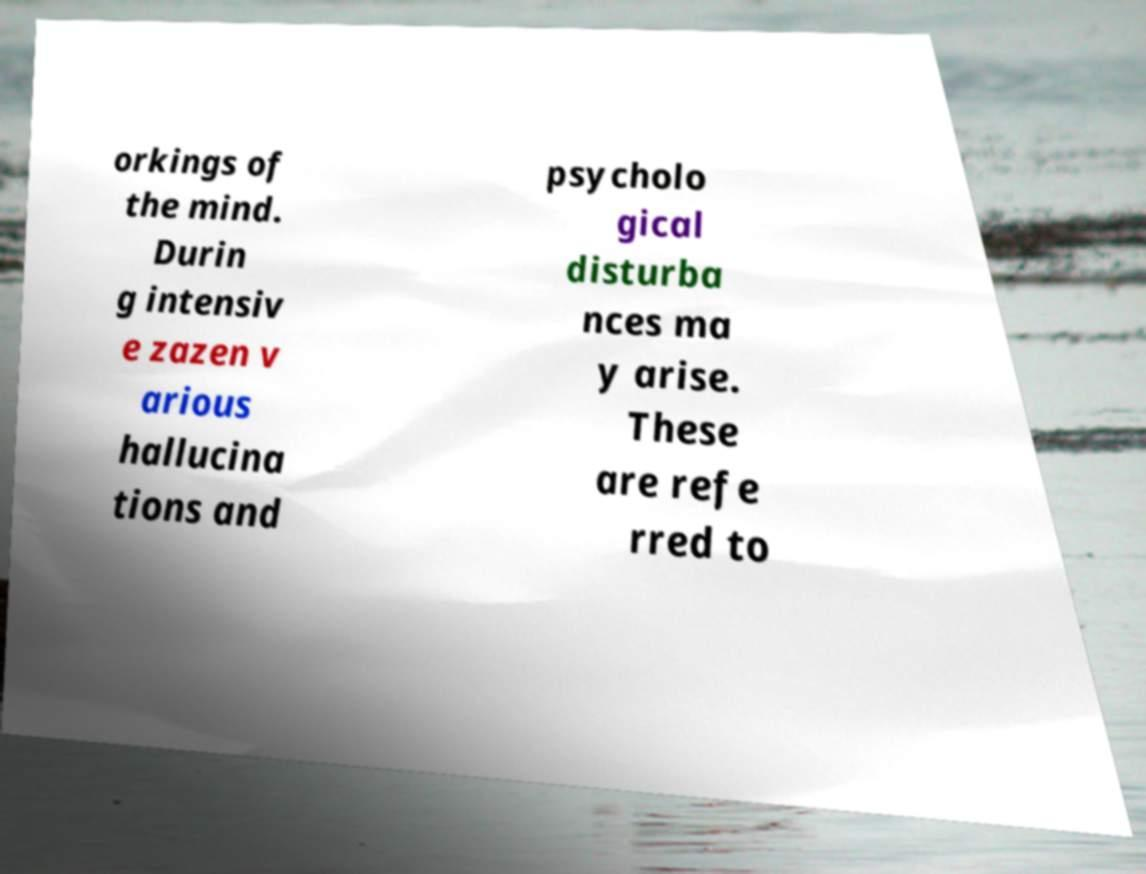Could you extract and type out the text from this image? orkings of the mind. Durin g intensiv e zazen v arious hallucina tions and psycholo gical disturba nces ma y arise. These are refe rred to 